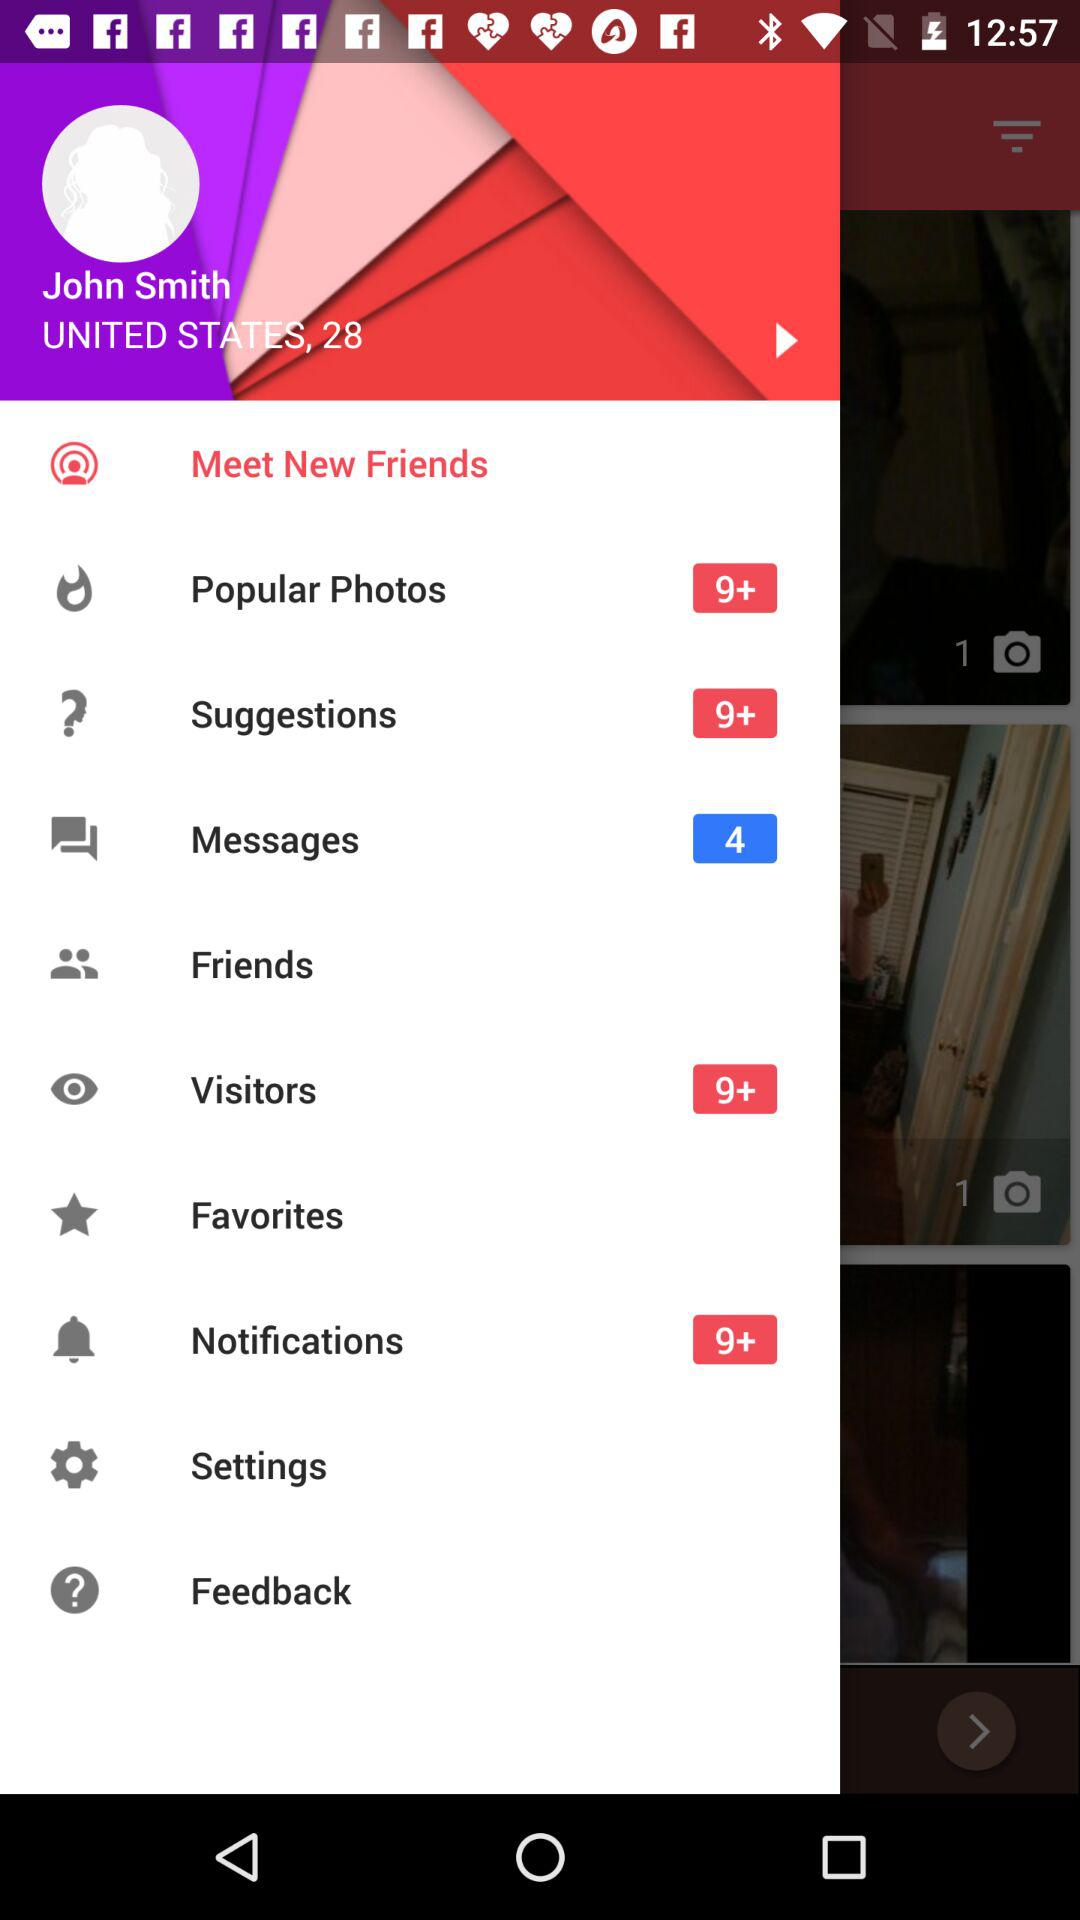What's the count of popular photos? The count of popular photos is more than 9. 